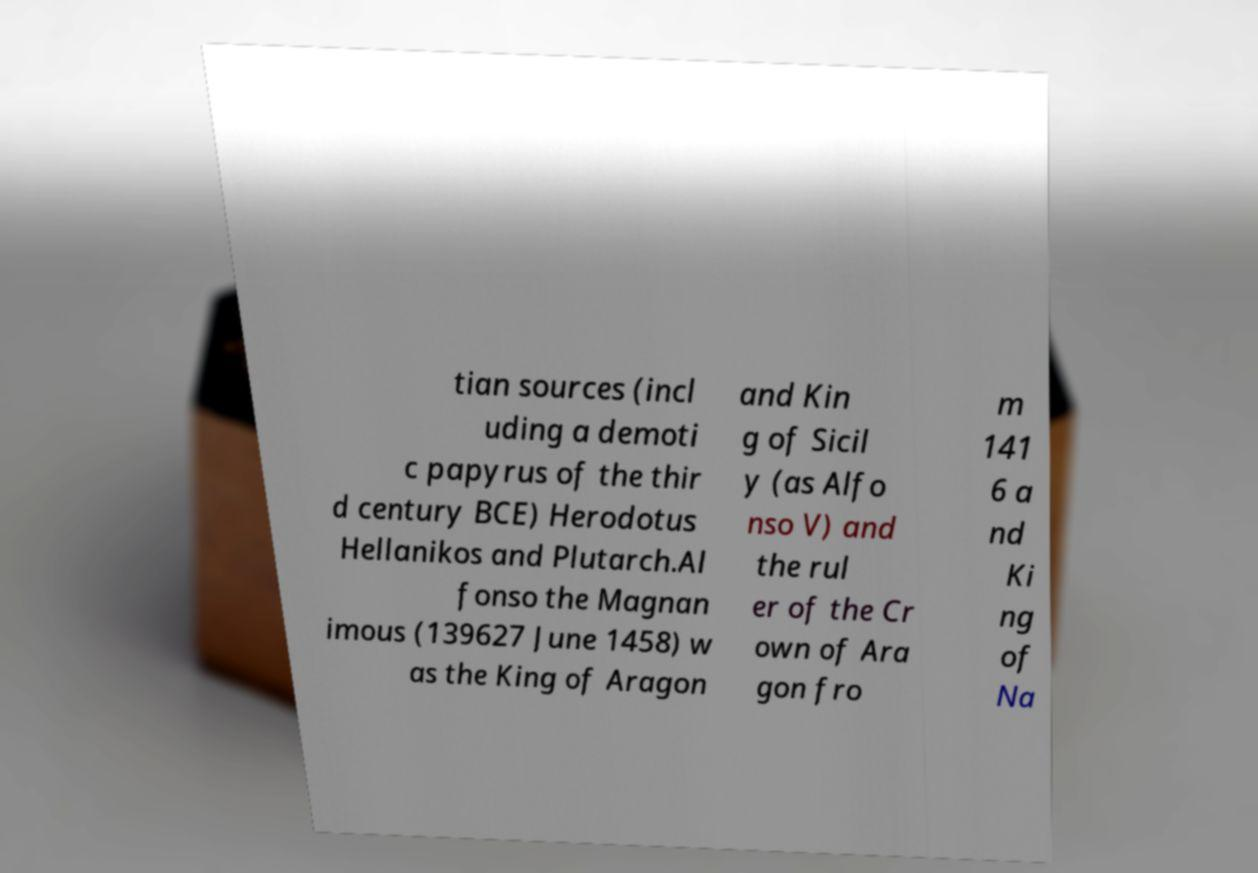I need the written content from this picture converted into text. Can you do that? tian sources (incl uding a demoti c papyrus of the thir d century BCE) Herodotus Hellanikos and Plutarch.Al fonso the Magnan imous (139627 June 1458) w as the King of Aragon and Kin g of Sicil y (as Alfo nso V) and the rul er of the Cr own of Ara gon fro m 141 6 a nd Ki ng of Na 